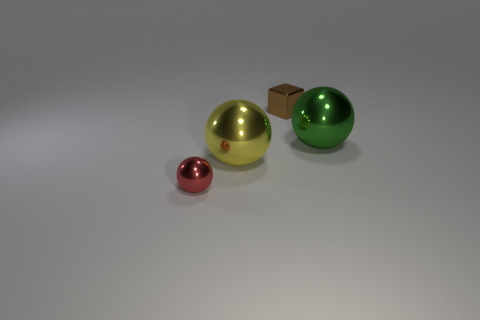What material is the other big object that is the same shape as the green metallic thing?
Offer a very short reply. Metal. The small metallic block has what color?
Offer a terse response. Brown. The shiny thing behind the big sphere on the right side of the tiny brown object is what color?
Your answer should be very brief. Brown. Does the small metallic cube have the same color as the large object left of the green metallic sphere?
Your answer should be compact. No. There is a big yellow metal thing to the left of the tiny thing right of the small red metallic sphere; what number of green objects are on the right side of it?
Keep it short and to the point. 1. There is a green shiny ball; are there any metal spheres left of it?
Provide a succinct answer. Yes. Is there anything else that is the same color as the block?
Offer a terse response. No. How many spheres are tiny brown shiny objects or big green objects?
Offer a terse response. 1. How many objects are on the right side of the small red sphere and in front of the tiny cube?
Keep it short and to the point. 2. Are there an equal number of big green metal things in front of the tiny brown metallic thing and tiny objects to the left of the big yellow shiny ball?
Your answer should be very brief. Yes. 